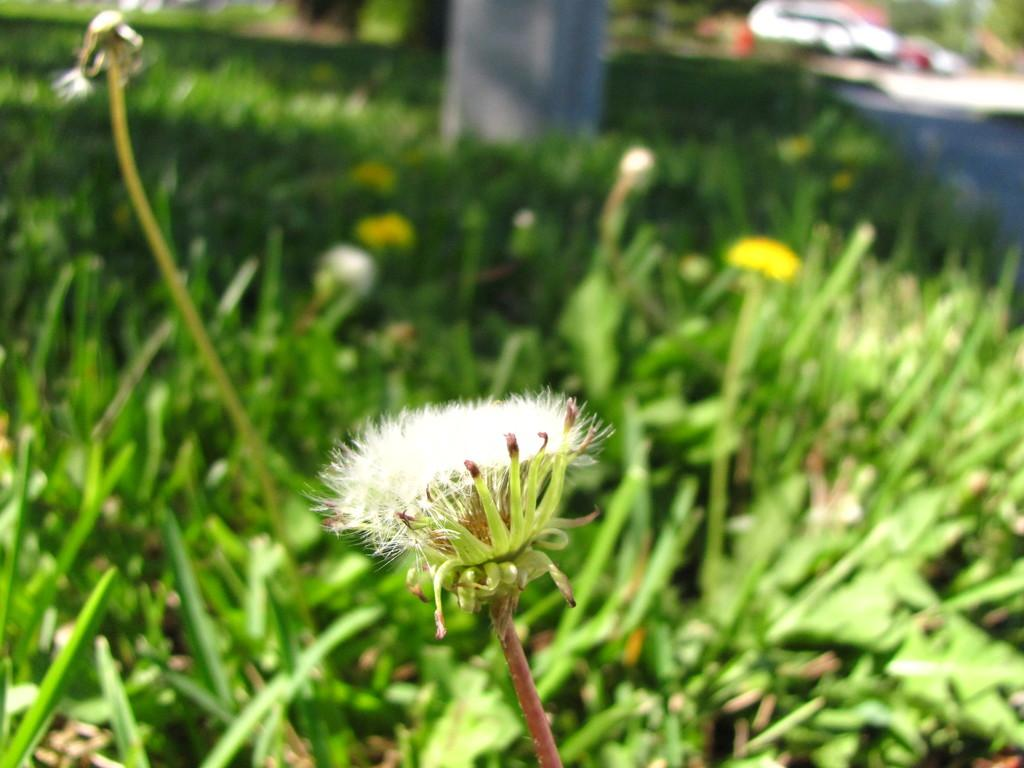What type of plants can be seen in the image? There are plants with flowers in the image. Can you describe the background of the image? The background of the image is blurry. What color is the scarf that the father is wearing in the image? There is no scarf or father present in the image; it only features plants with flowers and a blurry background. 